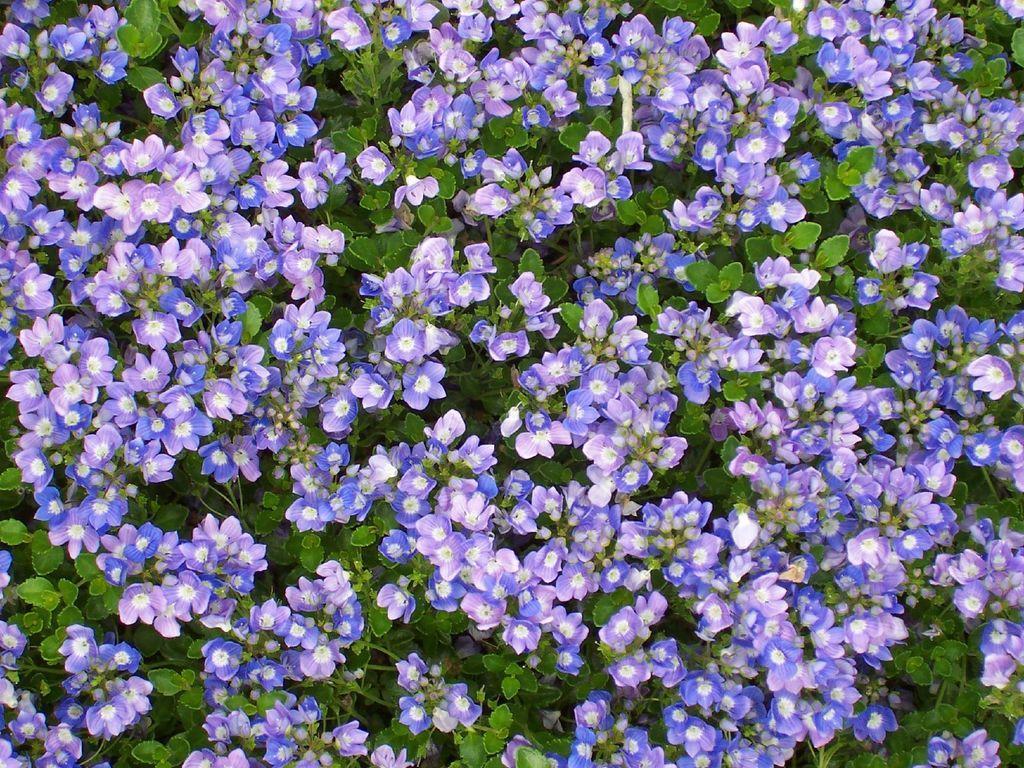How would you summarize this image in a sentence or two? In this picture we can see flowers and plants. 